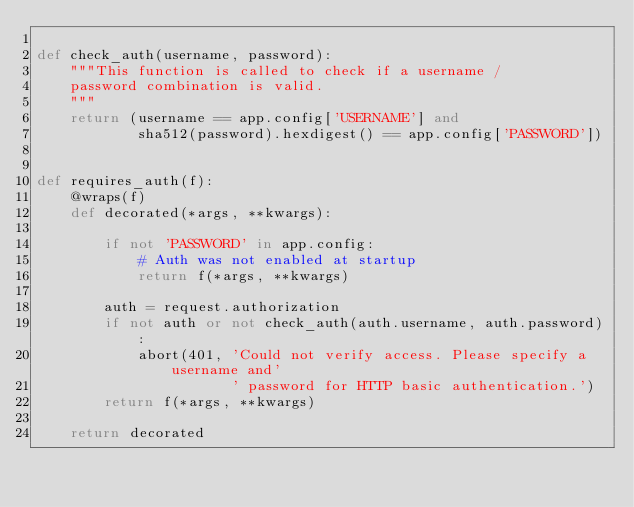<code> <loc_0><loc_0><loc_500><loc_500><_Python_>
def check_auth(username, password):
    """This function is called to check if a username /
    password combination is valid.
    """
    return (username == app.config['USERNAME'] and
            sha512(password).hexdigest() == app.config['PASSWORD'])


def requires_auth(f):
    @wraps(f)
    def decorated(*args, **kwargs):

        if not 'PASSWORD' in app.config:
            # Auth was not enabled at startup
            return f(*args, **kwargs)

        auth = request.authorization
        if not auth or not check_auth(auth.username, auth.password):
            abort(401, 'Could not verify access. Please specify a username and'
                       ' password for HTTP basic authentication.')
        return f(*args, **kwargs)
    
    return decorated
</code> 